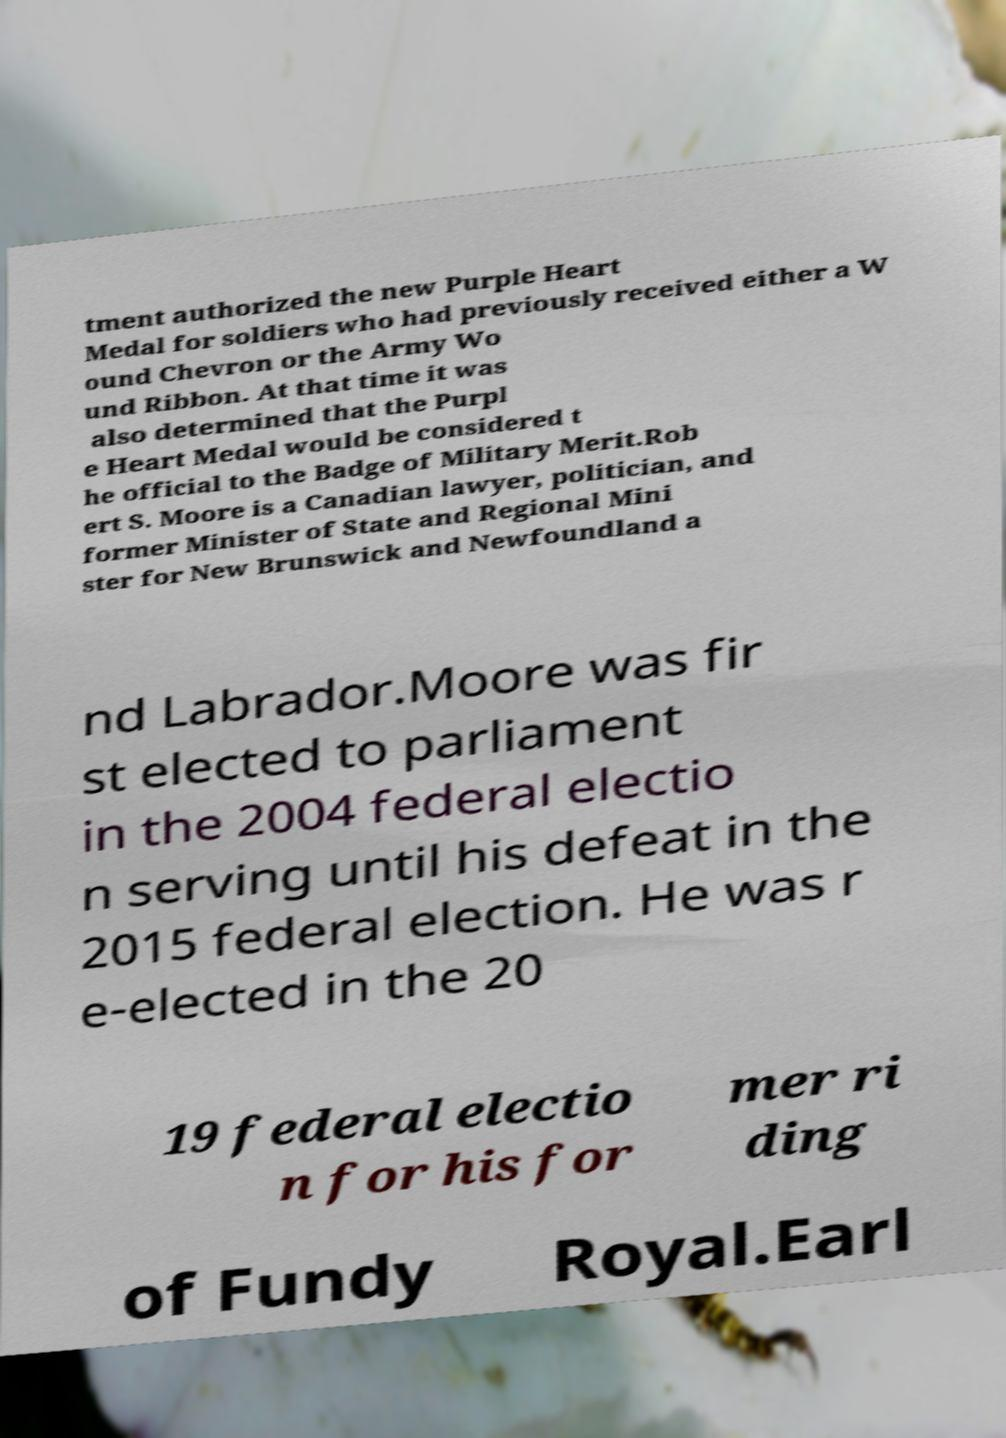Please identify and transcribe the text found in this image. tment authorized the new Purple Heart Medal for soldiers who had previously received either a W ound Chevron or the Army Wo und Ribbon. At that time it was also determined that the Purpl e Heart Medal would be considered t he official to the Badge of Military Merit.Rob ert S. Moore is a Canadian lawyer, politician, and former Minister of State and Regional Mini ster for New Brunswick and Newfoundland a nd Labrador.Moore was fir st elected to parliament in the 2004 federal electio n serving until his defeat in the 2015 federal election. He was r e-elected in the 20 19 federal electio n for his for mer ri ding of Fundy Royal.Earl 